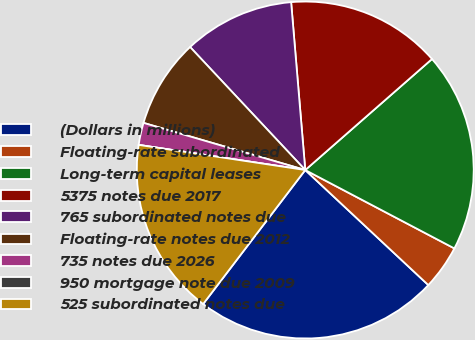Convert chart. <chart><loc_0><loc_0><loc_500><loc_500><pie_chart><fcel>(Dollars in millions)<fcel>Floating-rate subordinated<fcel>Long-term capital leases<fcel>5375 notes due 2017<fcel>765 subordinated notes due<fcel>Floating-rate notes due 2012<fcel>735 notes due 2026<fcel>950 mortgage note due 2009<fcel>525 subordinated notes due<nl><fcel>23.4%<fcel>4.26%<fcel>19.15%<fcel>14.89%<fcel>10.64%<fcel>8.51%<fcel>2.13%<fcel>0.0%<fcel>17.02%<nl></chart> 